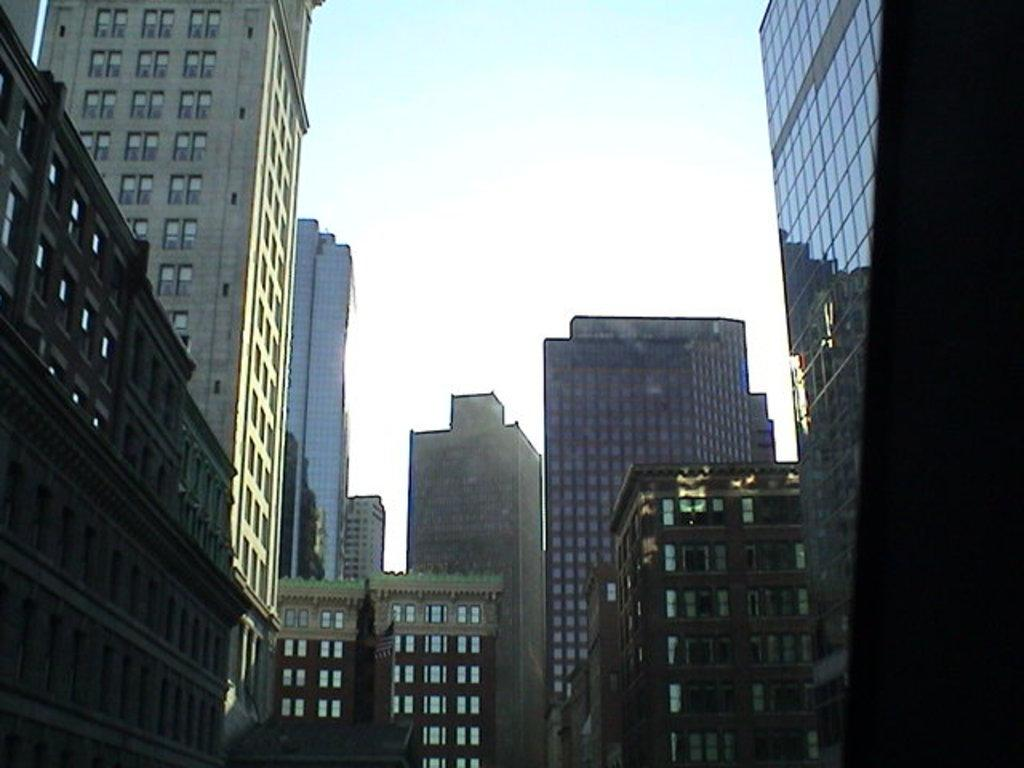What type of structures can be seen in the image? There are buildings in the image. What type of pen is being used to draw the buildings in the image? There is no pen present in the image, as the buildings are real structures and not a drawing. 